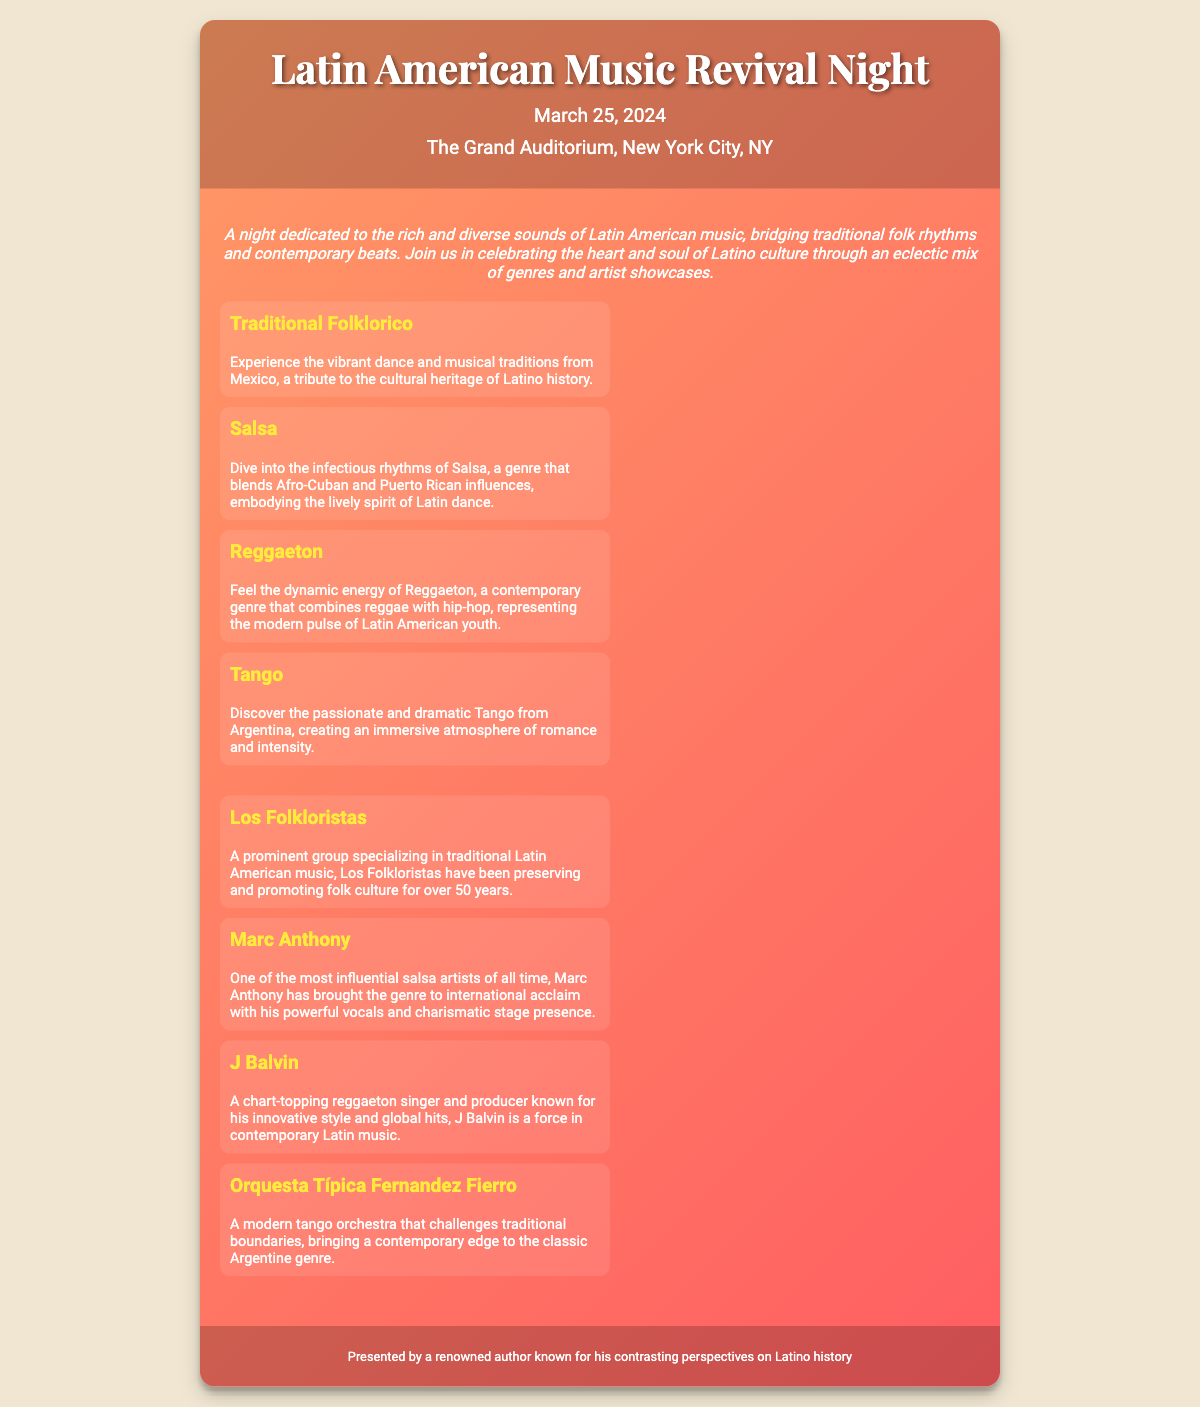What is the date of the event? The date of the event is stated in the document as March 25, 2024.
Answer: March 25, 2024 What is the venue for the concert? The venue where the concert is held is mentioned as The Grand Auditorium, New York City, NY.
Answer: The Grand Auditorium, New York City, NY Which genre features vibrant dance and musical traditions from Mexico? The document specifies that Traditional Folklorico is the genre that showcases vibrant dance and musical traditions from Mexico.
Answer: Traditional Folklorico Who is known as one of the most influential salsa artists? The document mentions Marc Anthony as one of the most influential salsa artists of all time.
Answer: Marc Anthony What type of music does J Balvin represent? The document indicates that J Balvin is known for his contributions to the contemporary genre of Reggaeton.
Answer: Reggaeton Which group has been preserving and promoting folk culture for over 50 years? According to the document, Los Folkloristas have been preserving and promoting folk culture for over 50 years.
Answer: Los Folkloristas What does the event celebrate? The document states the event celebrates the rich and diverse sounds of Latin American music, bridging traditional folk rhythms and contemporary beats.
Answer: Latin American music How many genres are detailed in the document? The document lists four genres of music being performed during the event.
Answer: Four What kind of atmosphere does the Tango genre create? The document describes the Tango genre as creating an immersive atmosphere of romance and intensity.
Answer: Romance and intensity 